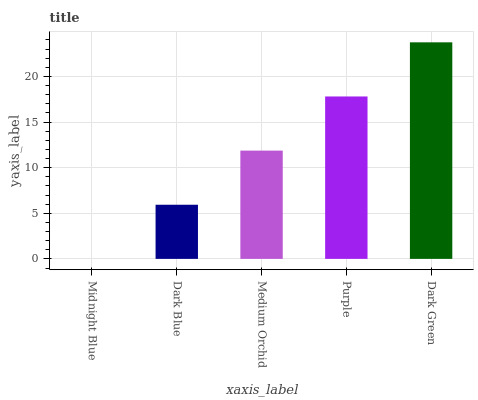Is Midnight Blue the minimum?
Answer yes or no. Yes. Is Dark Green the maximum?
Answer yes or no. Yes. Is Dark Blue the minimum?
Answer yes or no. No. Is Dark Blue the maximum?
Answer yes or no. No. Is Dark Blue greater than Midnight Blue?
Answer yes or no. Yes. Is Midnight Blue less than Dark Blue?
Answer yes or no. Yes. Is Midnight Blue greater than Dark Blue?
Answer yes or no. No. Is Dark Blue less than Midnight Blue?
Answer yes or no. No. Is Medium Orchid the high median?
Answer yes or no. Yes. Is Medium Orchid the low median?
Answer yes or no. Yes. Is Purple the high median?
Answer yes or no. No. Is Dark Green the low median?
Answer yes or no. No. 